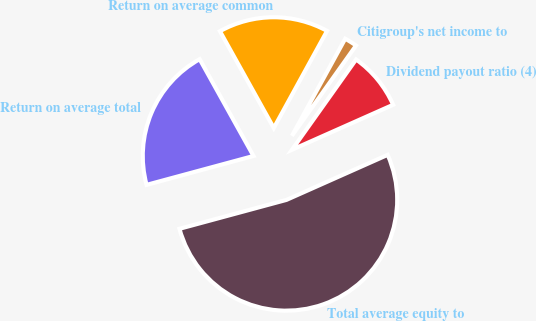<chart> <loc_0><loc_0><loc_500><loc_500><pie_chart><fcel>Citigroup's net income to<fcel>Return on average common<fcel>Return on average total<fcel>Total average equity to<fcel>Dividend payout ratio (4)<nl><fcel>1.84%<fcel>16.07%<fcel>21.12%<fcel>52.46%<fcel>8.51%<nl></chart> 